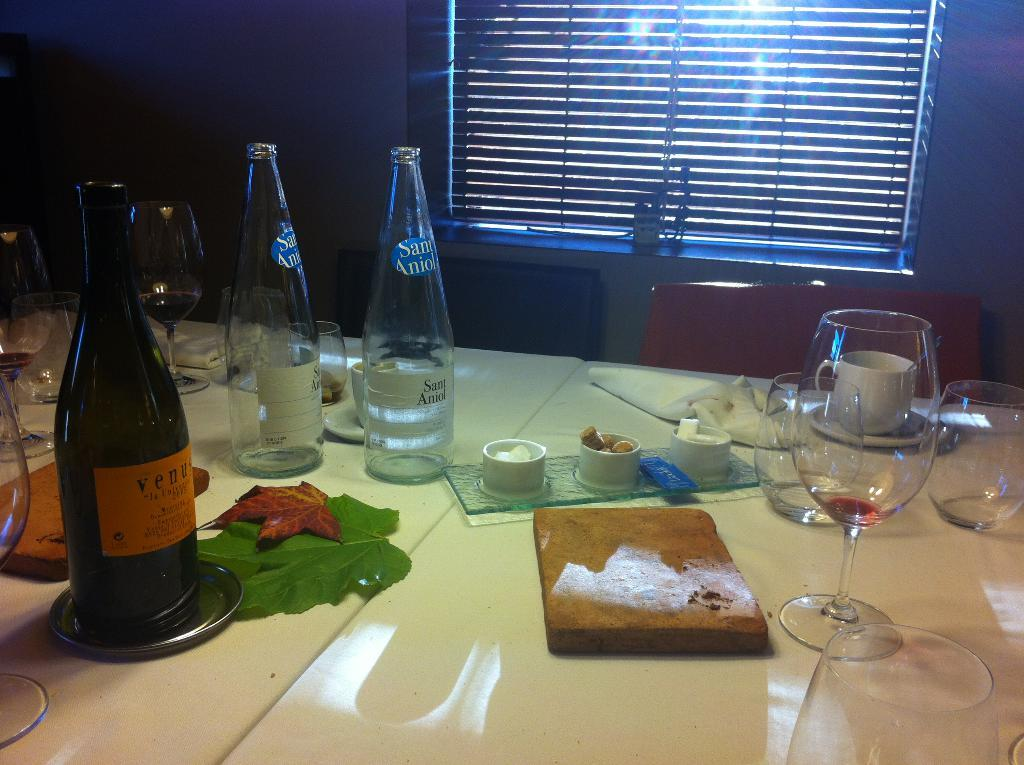What type of beverage container is on the table in the image? There is a wine bottle on the table. What else is on the table that might be used for drinking? There is a glass on the table. What type of food item is on the table? There is a piece of bread on the table. What natural element is on the table? There is a leaf on the table. What might be used for cleaning or wiping in the image? Tissues are on the table. How many fangs can be seen on the bread in the image? There are no fangs present on the bread in the image. What type of addition can be seen on the wine bottle in the image? There is no addition visible on the wine bottle in the image. 